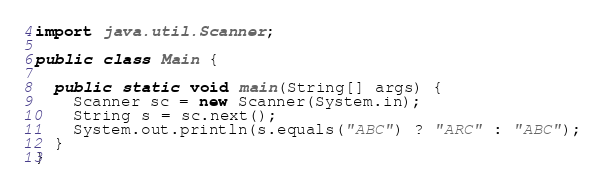<code> <loc_0><loc_0><loc_500><loc_500><_Java_>import java.util.Scanner;

public class Main {

  public static void main(String[] args) {
    Scanner sc = new Scanner(System.in);
    String s = sc.next();
    System.out.println(s.equals("ABC") ? "ARC" : "ABC");
  }
}</code> 